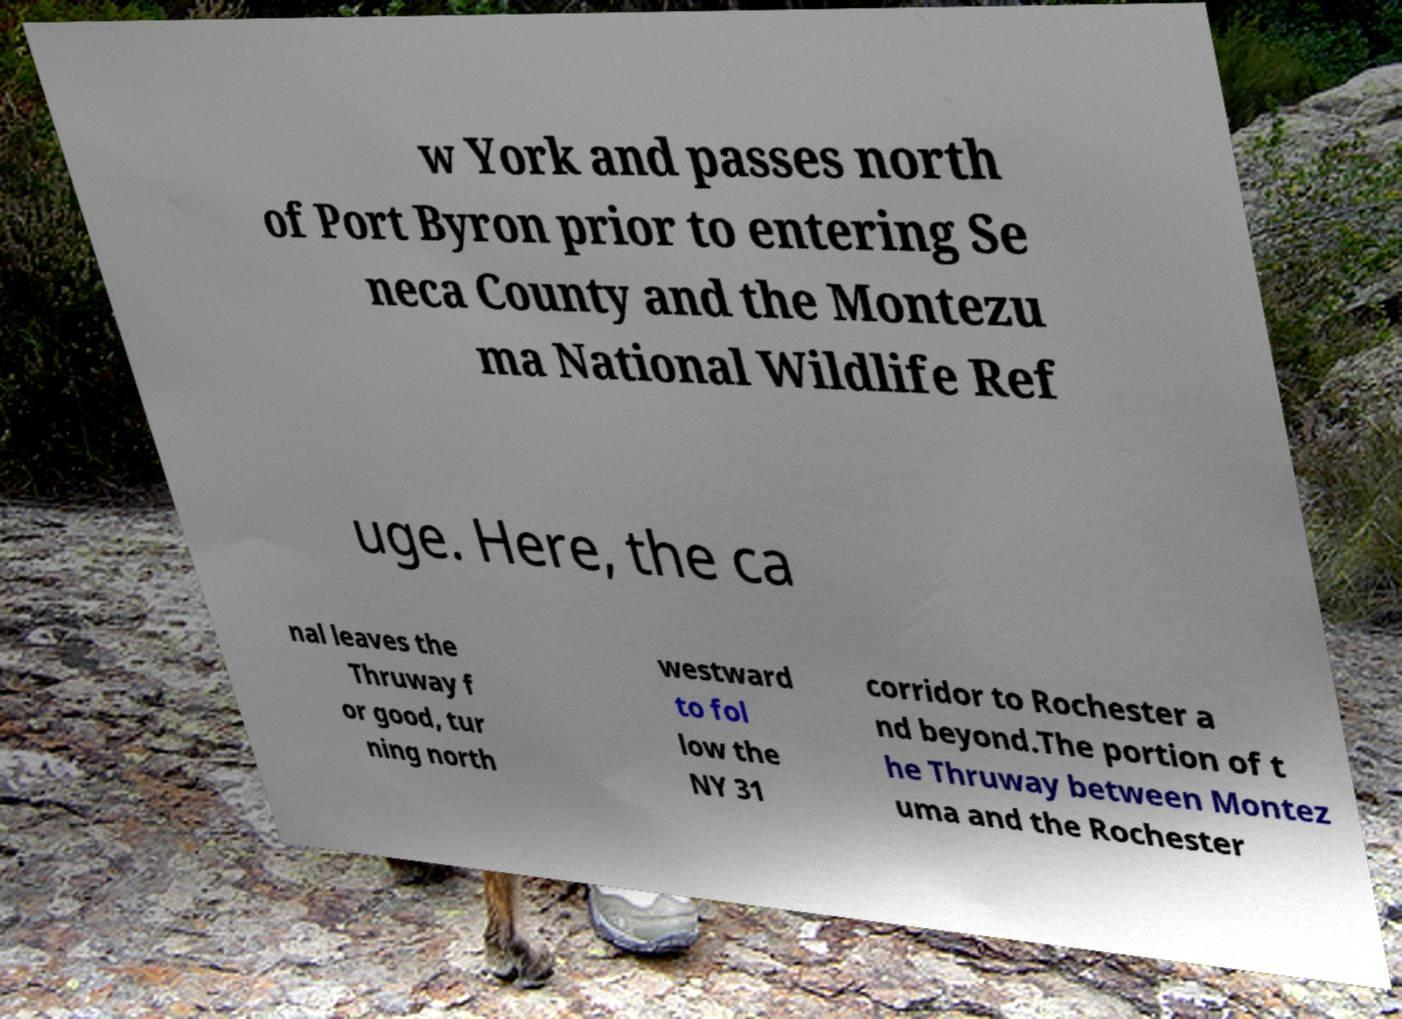Please identify and transcribe the text found in this image. w York and passes north of Port Byron prior to entering Se neca County and the Montezu ma National Wildlife Ref uge. Here, the ca nal leaves the Thruway f or good, tur ning north westward to fol low the NY 31 corridor to Rochester a nd beyond.The portion of t he Thruway between Montez uma and the Rochester 